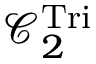Convert formula to latex. <formula><loc_0><loc_0><loc_500><loc_500>\mathcal { C } _ { 2 } ^ { T r i }</formula> 